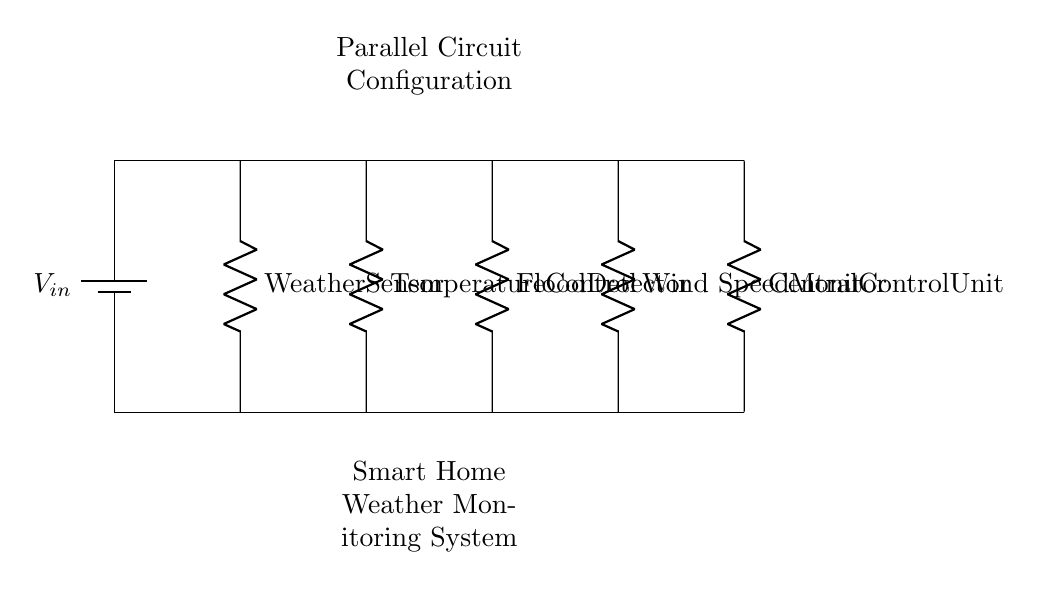What components are included in the circuit? The circuit includes five components: a weather sensor, temperature control, flood detector, wind speed monitor, and a central control unit. Each of these is represented as a resistor in the diagram.
Answer: weather sensor, temperature control, flood detector, wind speed monitor, central control unit How many branches are there in the circuit? The circuit diagram shows a total of five branches that represent the different sensors and units; they are all connected parallel to each other.
Answer: five Which component is closest to the power source? The weather sensor is connected directly to the top line of the circuit, closest to the power source.
Answer: weather sensor What type of circuit configuration is used? The circuit is arranged in a parallel configuration, allowing each component to operate independently while being connected to the same power source.
Answer: parallel What happens if the flood detector fails? Since this is a parallel circuit, if the flood detector fails, the remaining components (weather sensor, temperature control, and wind speed monitor) will still function normally.
Answer: remaining components still function How can the central control unit respond to extreme weather? The central control unit can receive input from all other sensors (weather sensor, temperature control, flood detector, wind speed monitor) and take appropriate actions based on the readings.
Answer: processes input from all sensors 